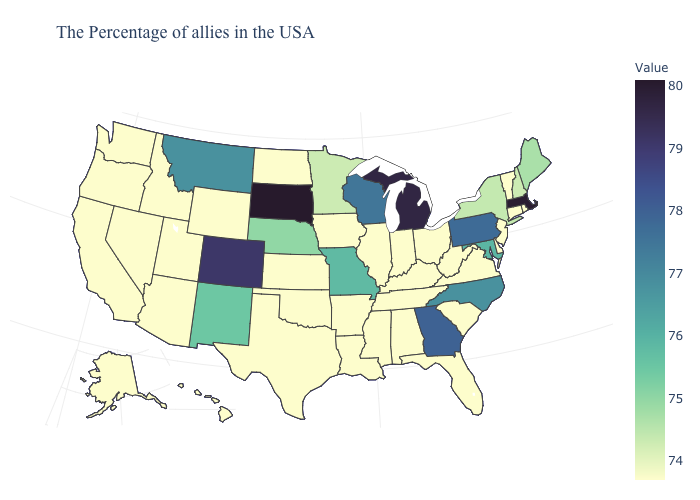Among the states that border North Carolina , does Georgia have the lowest value?
Write a very short answer. No. Does Virginia have a higher value than New Mexico?
Short answer required. No. Among the states that border Vermont , does New York have the highest value?
Concise answer only. No. Does the map have missing data?
Concise answer only. No. Which states have the lowest value in the MidWest?
Give a very brief answer. Ohio, Indiana, Illinois, Iowa, Kansas, North Dakota. Does Missouri have the lowest value in the MidWest?
Concise answer only. No. Among the states that border Georgia , which have the highest value?
Short answer required. North Carolina. 